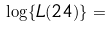<formula> <loc_0><loc_0><loc_500><loc_500>\log \{ L ( 2 4 ) \} = \\</formula> 